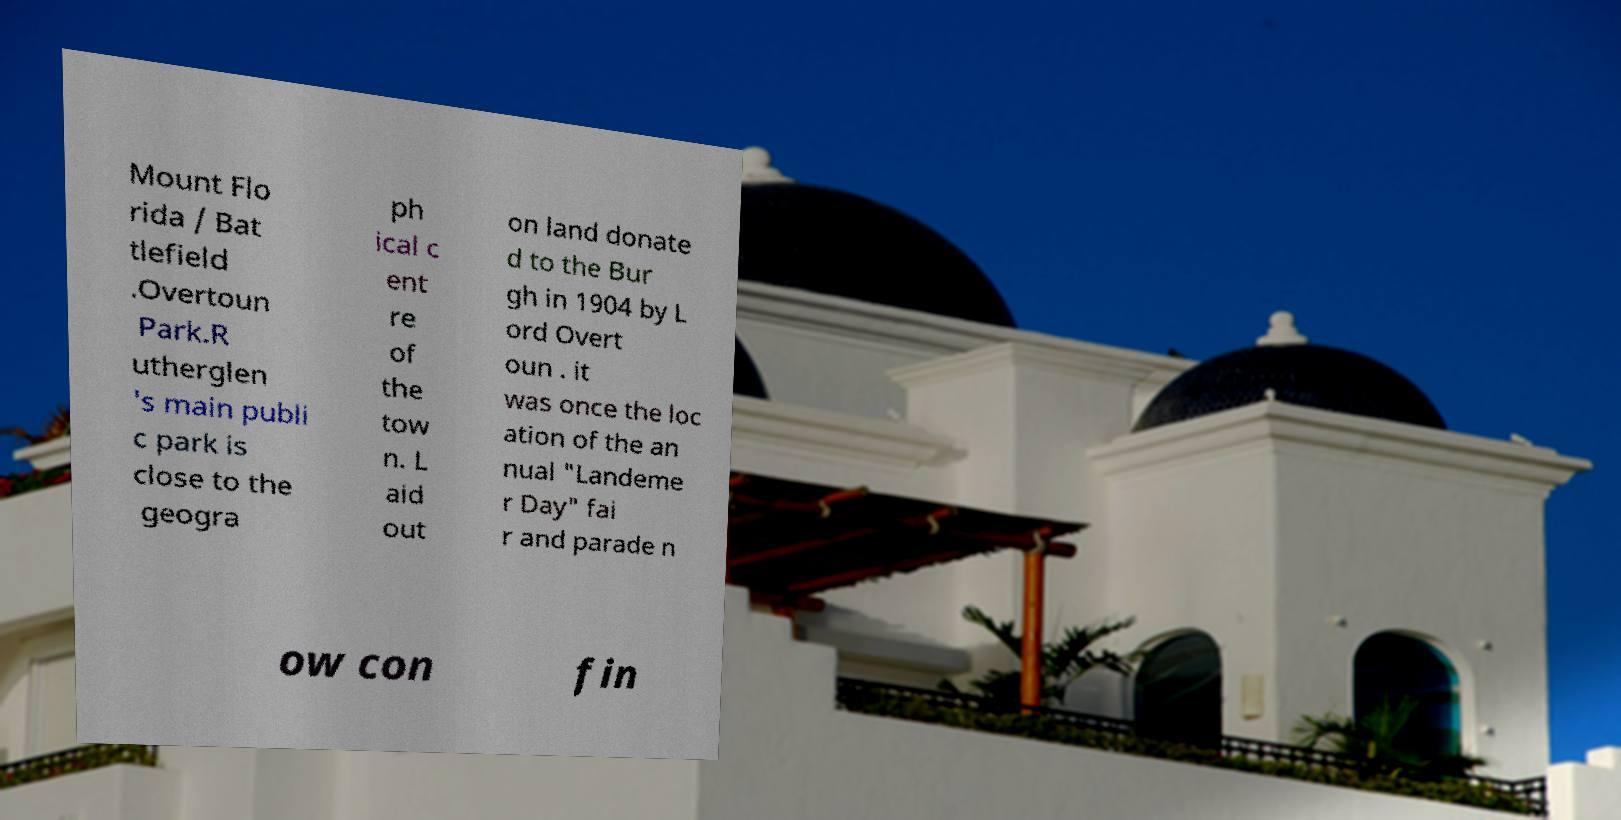Can you accurately transcribe the text from the provided image for me? Mount Flo rida / Bat tlefield .Overtoun Park.R utherglen 's main publi c park is close to the geogra ph ical c ent re of the tow n. L aid out on land donate d to the Bur gh in 1904 by L ord Overt oun . it was once the loc ation of the an nual "Landeme r Day" fai r and parade n ow con fin 